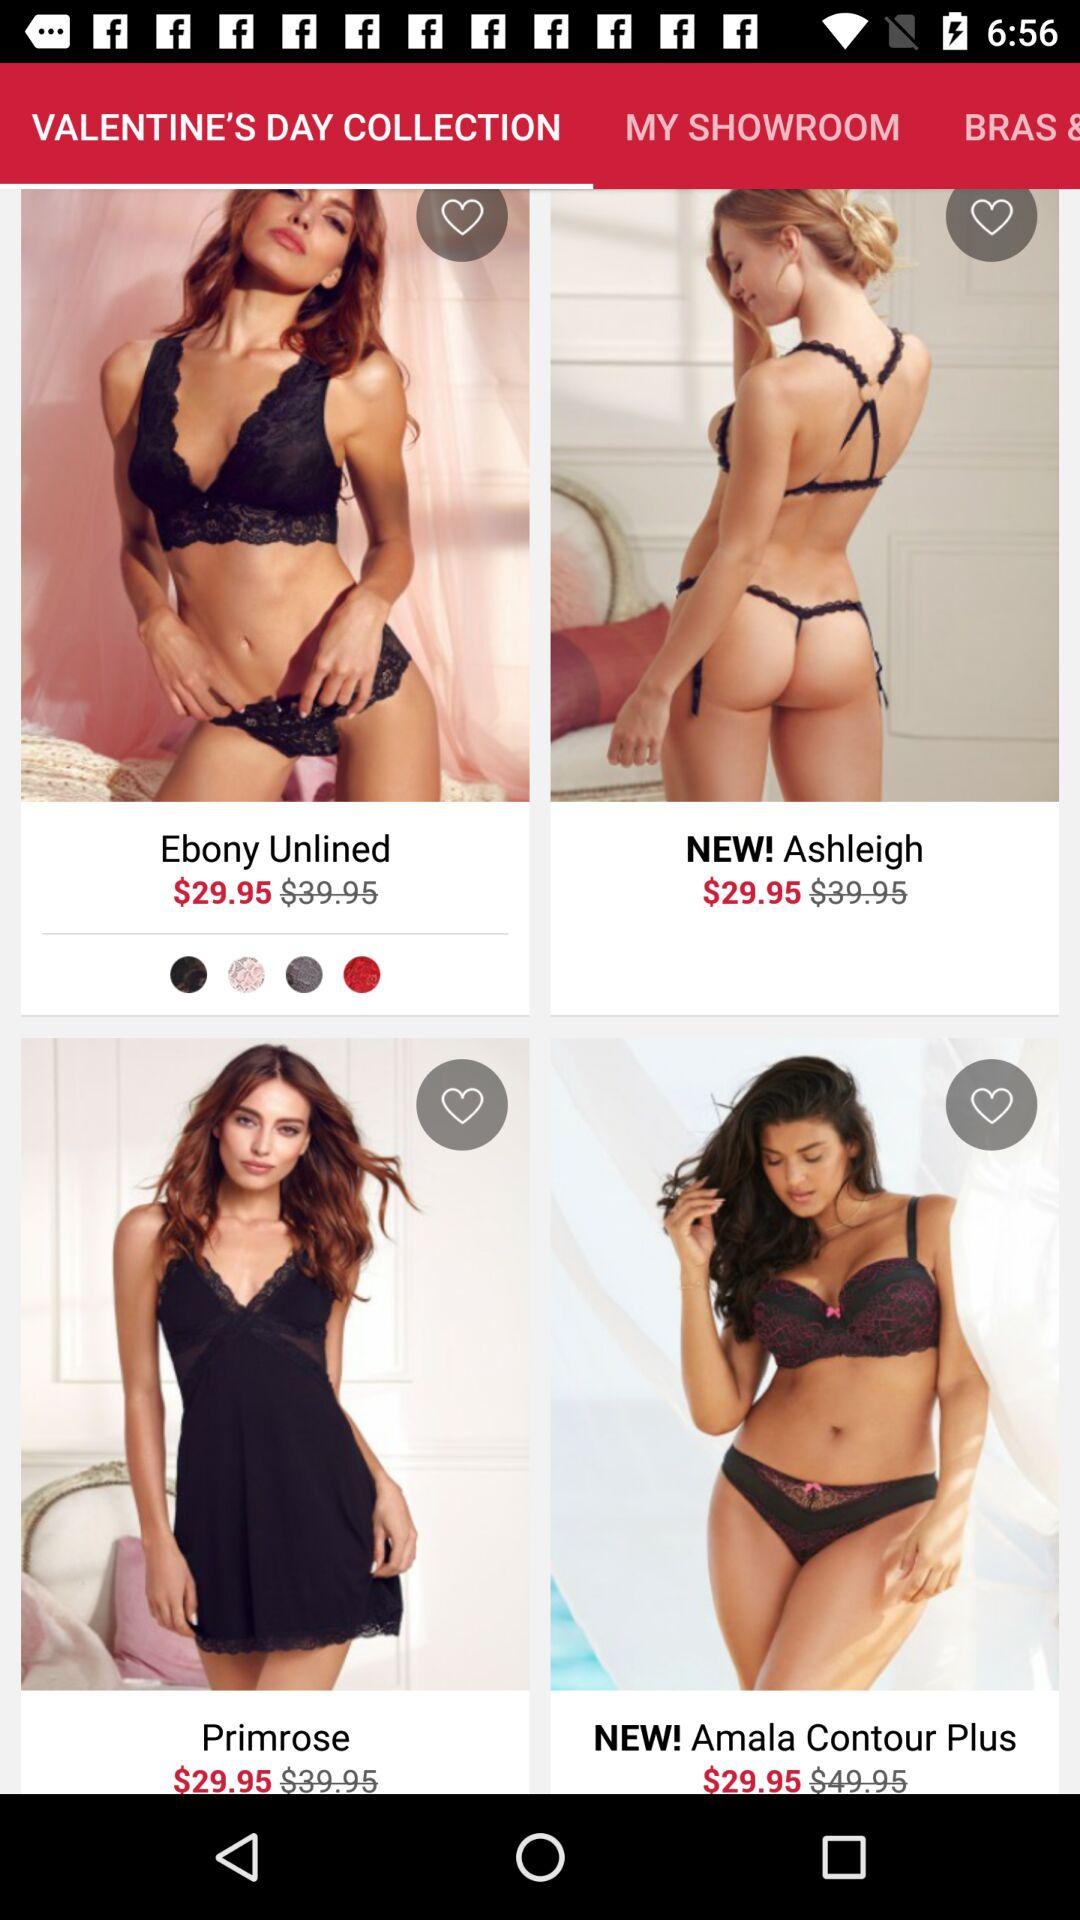What are the products newly added to the Valentine's Day Collection? The newly added products are "Ashleigh" and "Amala Contour Plus". 